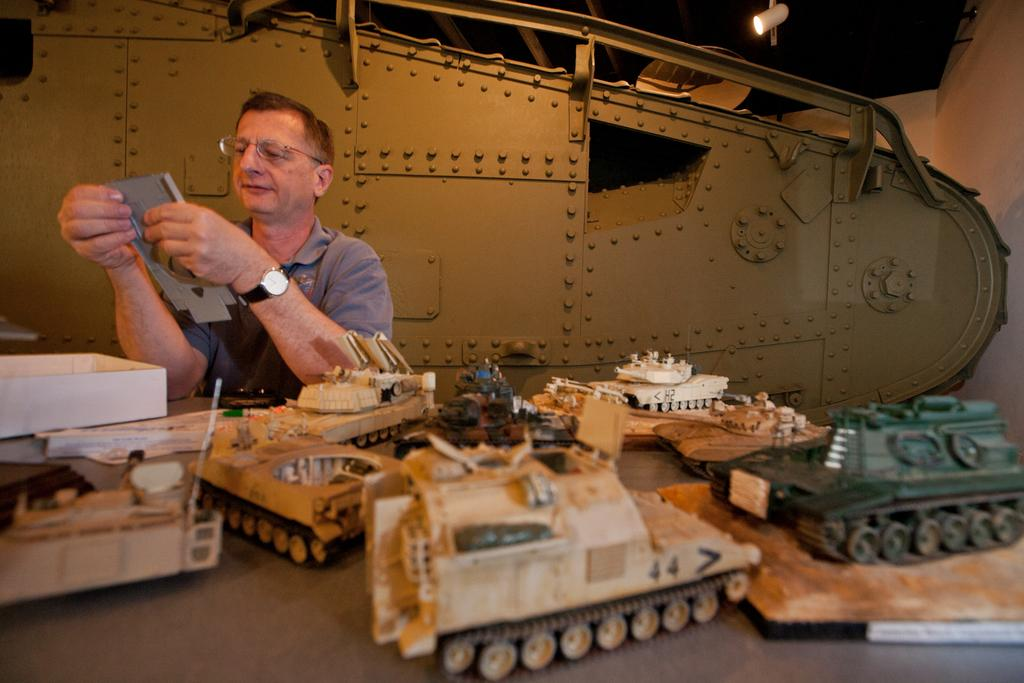What is the man doing in the image? The man is sitting on the left side of the image. What is the man holding in the image? The man is holding something in the image. What type of scene is depicted in the image? There are tank battles depicted in the image. What can be seen in the image that provides light? There is a light visible in the image. What type of fish can be seen swimming in the image? There are no fish present in the image; it features a man sitting and holding something, as well as tank battles. Can you tell me who created the whip used in the image? There is no whip present in the image, so it is not possible to determine who created it. 